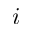<formula> <loc_0><loc_0><loc_500><loc_500>i</formula> 